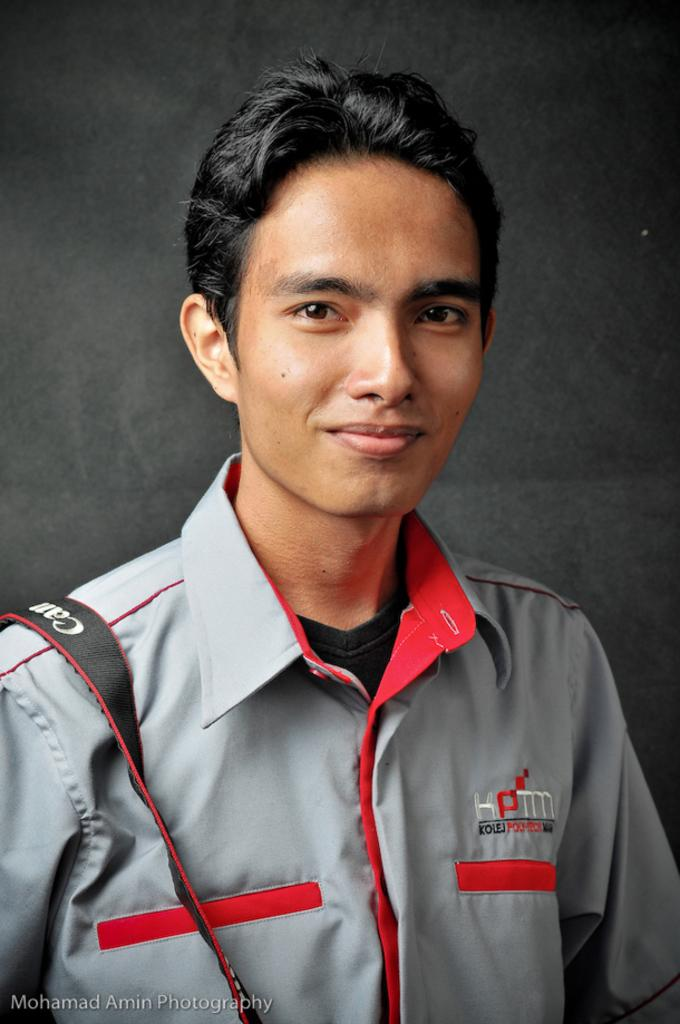<image>
Render a clear and concise summary of the photo. A young man with KPTM on his shirt has a camera strap over his shoulder. 